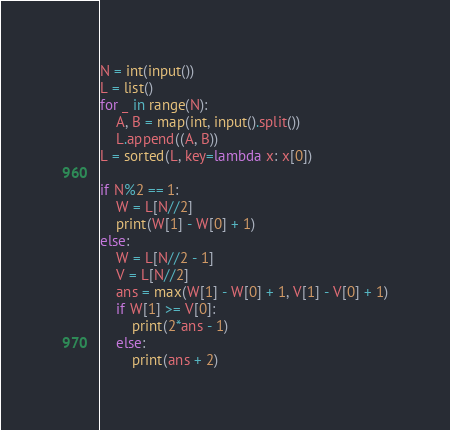Convert code to text. <code><loc_0><loc_0><loc_500><loc_500><_Python_>N = int(input())
L = list()
for _ in range(N):
    A, B = map(int, input().split())
    L.append((A, B))
L = sorted(L, key=lambda x: x[0])

if N%2 == 1:
    W = L[N//2]
    print(W[1] - W[0] + 1)
else:
    W = L[N//2 - 1]
    V = L[N//2]
    ans = max(W[1] - W[0] + 1, V[1] - V[0] + 1)
    if W[1] >= V[0]:
        print(2*ans - 1)
    else:
        print(ans + 2)
</code> 